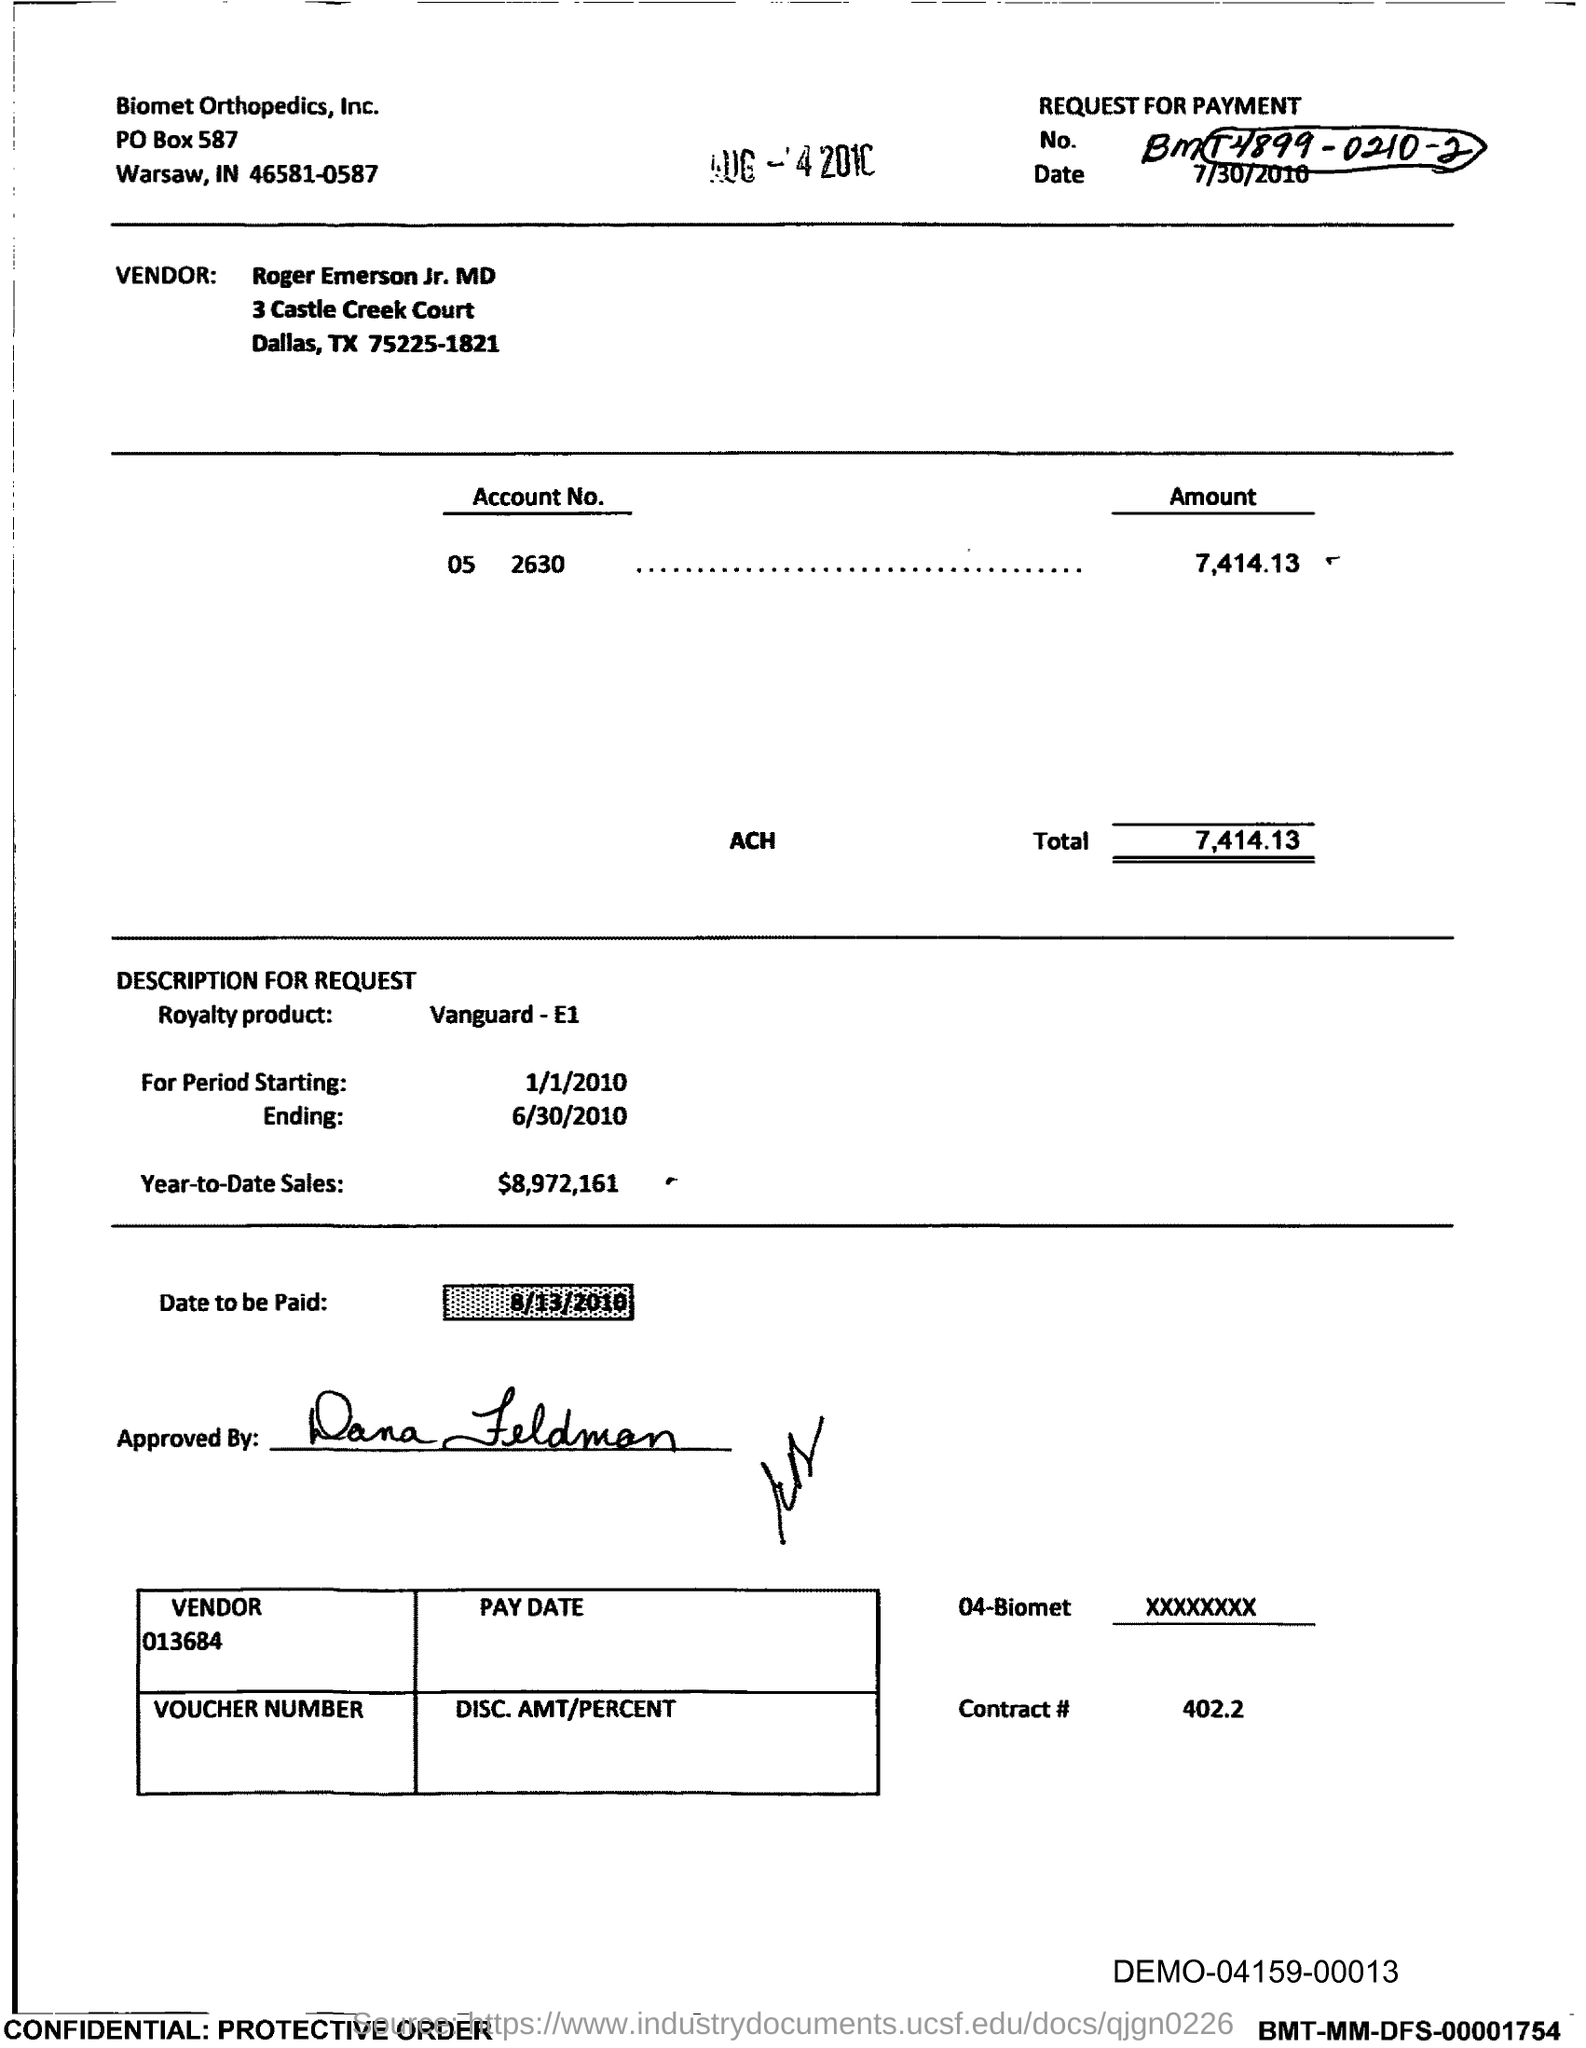What is the Total?
Give a very brief answer. 7,414.13. What is the Contract # Number?
Offer a very short reply. 402.2. 